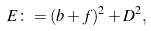<formula> <loc_0><loc_0><loc_500><loc_500>E \colon = ( b + f ) ^ { 2 } + D ^ { 2 } ,</formula> 